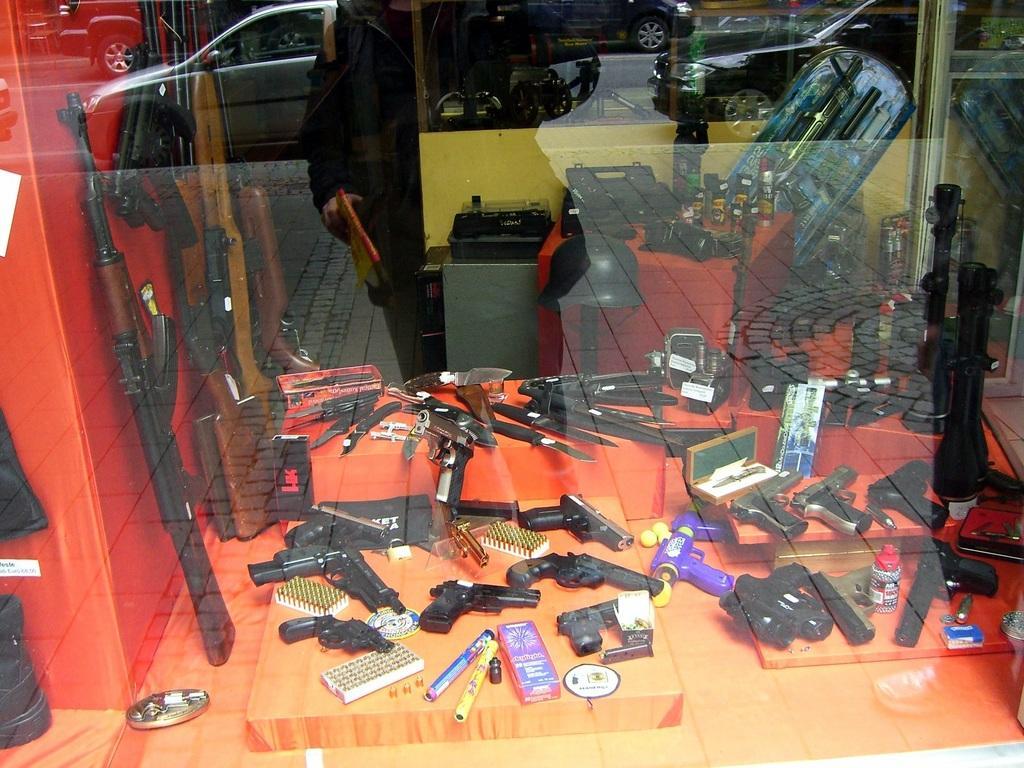Can you describe this image briefly? In this picture we can see a glass in the front, from the glass we can see different types of guns, knives, bullets, some boxes, a helmet and other things, we can see reflection of cars and a person on this glass. 